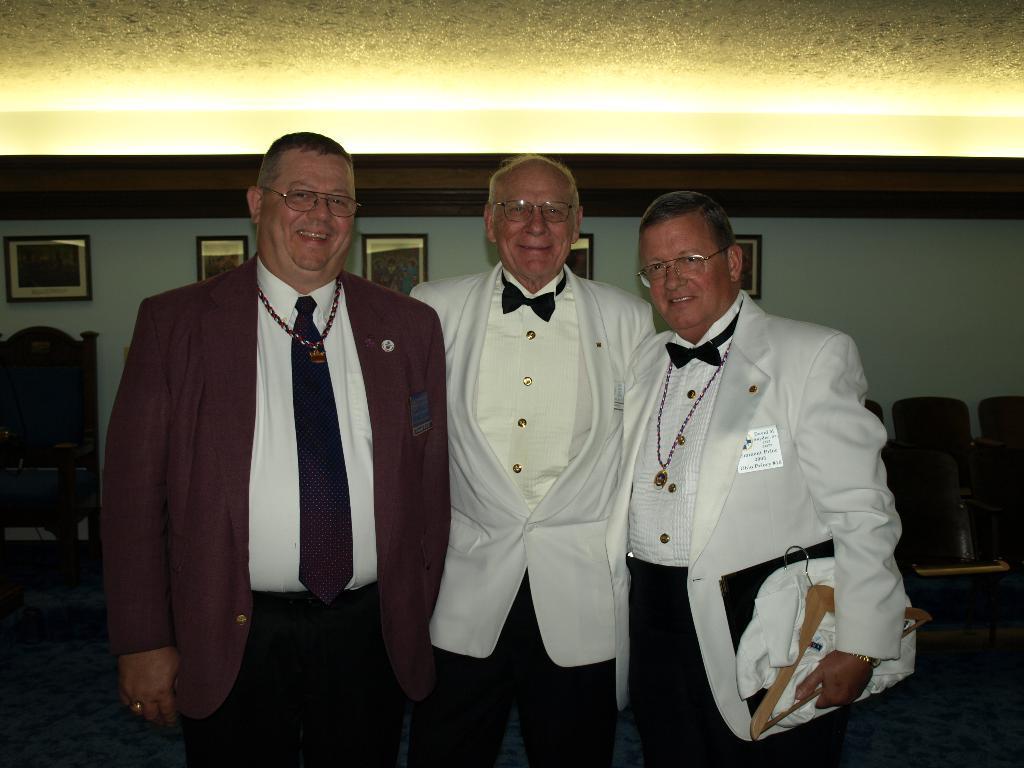Describe this image in one or two sentences. In this picture I can see few men standing and they wore spectacles on their faces and I can see a man holding a file, hanger and a cloth in his hand and I can see few photo frames on the wall and I can see few chairs and a table and I can see lights on the ceiling. 